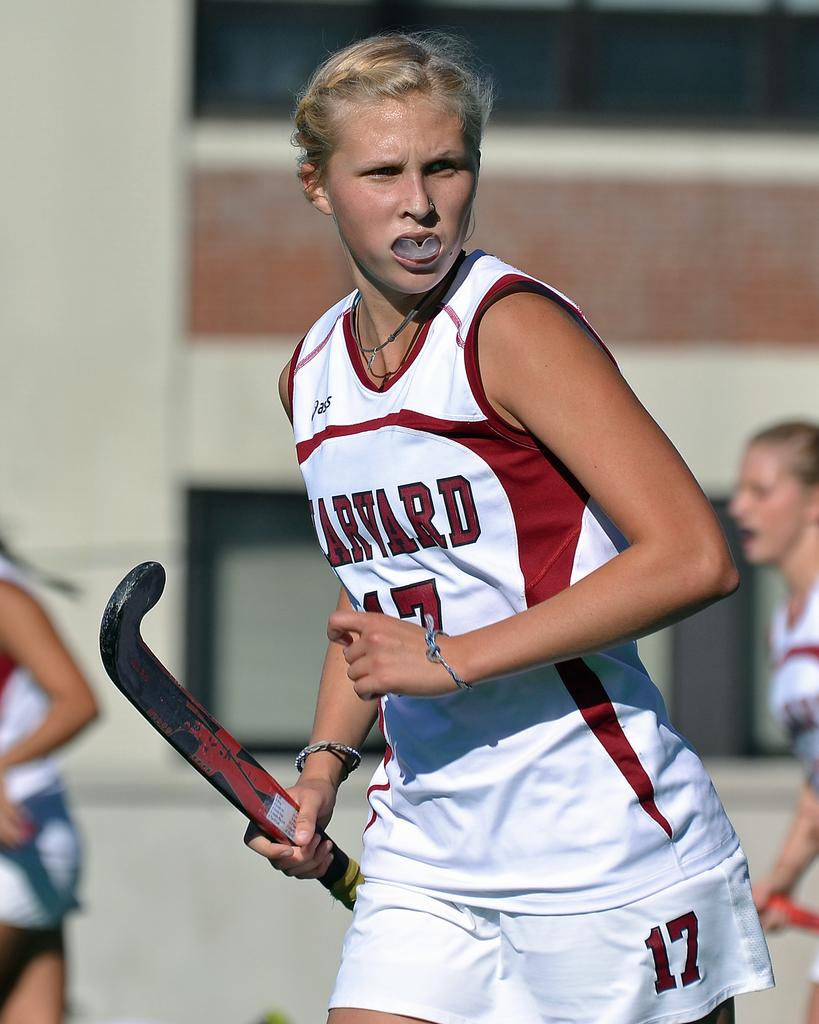<image>
Present a compact description of the photo's key features. the girl is wearing a Harvard number 17 jersey 